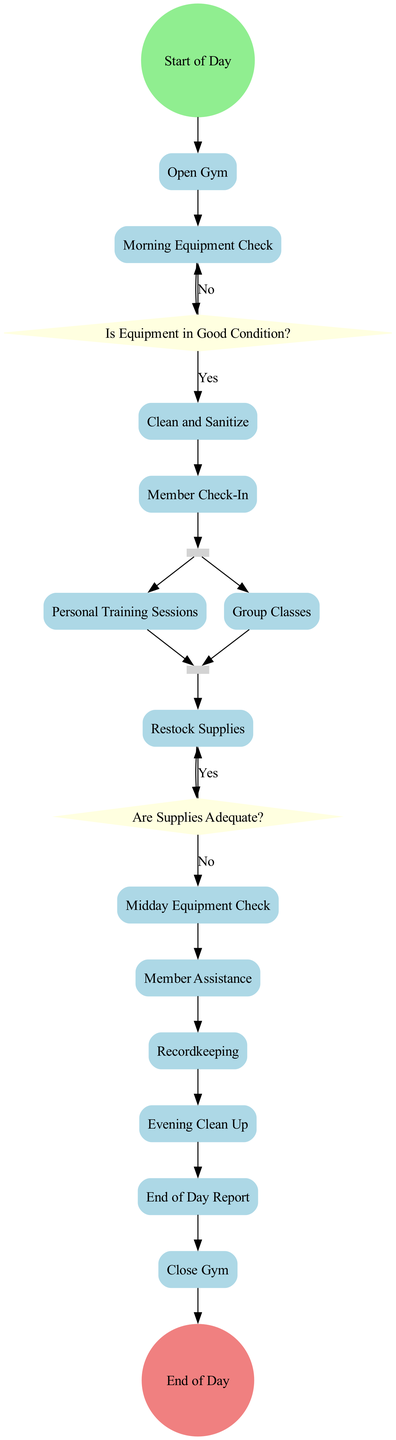What is the first action in the diagram? The diagram begins with the "Start of Day" event and the first action that follows it is "Open Gym".
Answer: Open Gym How many decisions are in the diagram? The diagram contains two decisions: "Is Equipment in Good Condition?" and "Are Supplies Adequate?" Therefore, the total count is two.
Answer: 2 What happens after the "Morning Equipment Check" action? After "Morning Equipment Check", the next step in the sequence is the decision "Is Equipment in Good Condition?".
Answer: Is Equipment in Good Condition? Which action follows the "End of Day Report"? The action that follows "End of Day Report" is "Close Gym", marking the conclusion of the day's operations.
Answer: Close Gym How does the diagram represent the simultaneous training activities? The diagram illustrates simultaneous training activities using a fork labeled "Perform Daily Training Activities", leading to both "Personal Training Sessions" and "Group Classes".
Answer: Perform Daily Training Activities How many actions occur before the "Member Check-In"? There are three actions that occur before "Member Check-In": "Open Gym", "Morning Equipment Check", and "Clean and Sanitize".
Answer: 3 What is the outcome if supplies are adequate during the "Are Supplies Adequate?" decision? If the supplies are adequate during this decision, the flow continues to "Recordkeeping" instead of moving to "Restock Supplies".
Answer: Recordkeeping What signifies the completion of all training activities in the diagram? The diagram indicates the completion of all training activities with a join node labeled "Training Activities End".
Answer: Training Activities End What is the purpose of the "Evening Clean Up" action? The purpose of the "Evening Clean Up" action is to perform a thorough cleaning of the gym before closing, ensuring hygiene and maintenance.
Answer: Perform a thorough cleaning 